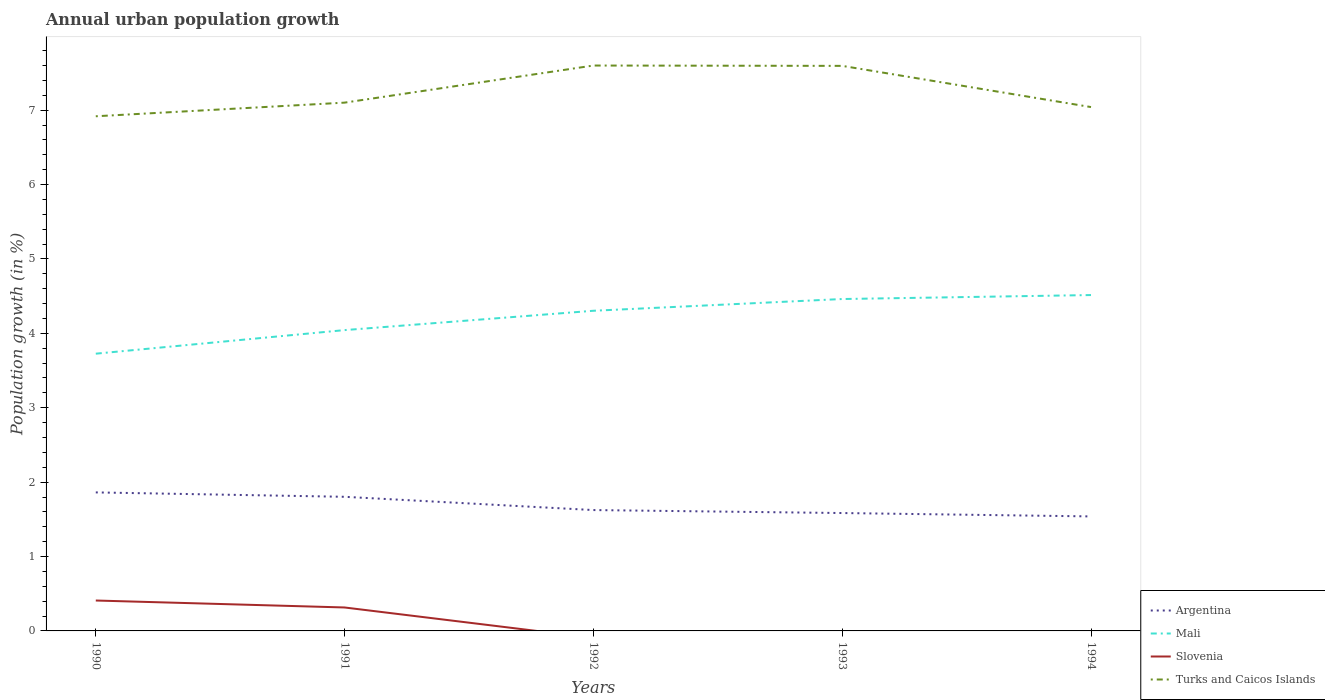Does the line corresponding to Turks and Caicos Islands intersect with the line corresponding to Argentina?
Your response must be concise. No. Is the number of lines equal to the number of legend labels?
Your answer should be very brief. No. Across all years, what is the maximum percentage of urban population growth in Mali?
Your answer should be very brief. 3.73. What is the total percentage of urban population growth in Argentina in the graph?
Keep it short and to the point. 0.24. What is the difference between the highest and the second highest percentage of urban population growth in Mali?
Give a very brief answer. 0.79. Is the percentage of urban population growth in Argentina strictly greater than the percentage of urban population growth in Slovenia over the years?
Keep it short and to the point. No. Where does the legend appear in the graph?
Give a very brief answer. Bottom right. How many legend labels are there?
Make the answer very short. 4. What is the title of the graph?
Your answer should be very brief. Annual urban population growth. Does "Korea (Republic)" appear as one of the legend labels in the graph?
Offer a terse response. No. What is the label or title of the X-axis?
Provide a short and direct response. Years. What is the label or title of the Y-axis?
Provide a succinct answer. Population growth (in %). What is the Population growth (in %) of Argentina in 1990?
Give a very brief answer. 1.86. What is the Population growth (in %) in Mali in 1990?
Your answer should be compact. 3.73. What is the Population growth (in %) in Slovenia in 1990?
Your response must be concise. 0.41. What is the Population growth (in %) of Turks and Caicos Islands in 1990?
Ensure brevity in your answer.  6.92. What is the Population growth (in %) in Argentina in 1991?
Ensure brevity in your answer.  1.8. What is the Population growth (in %) of Mali in 1991?
Offer a terse response. 4.04. What is the Population growth (in %) in Slovenia in 1991?
Your answer should be compact. 0.32. What is the Population growth (in %) in Turks and Caicos Islands in 1991?
Offer a terse response. 7.1. What is the Population growth (in %) in Argentina in 1992?
Your response must be concise. 1.62. What is the Population growth (in %) in Mali in 1992?
Offer a terse response. 4.3. What is the Population growth (in %) in Slovenia in 1992?
Provide a short and direct response. 0. What is the Population growth (in %) of Turks and Caicos Islands in 1992?
Keep it short and to the point. 7.6. What is the Population growth (in %) in Argentina in 1993?
Your answer should be compact. 1.58. What is the Population growth (in %) in Mali in 1993?
Give a very brief answer. 4.46. What is the Population growth (in %) of Turks and Caicos Islands in 1993?
Your response must be concise. 7.6. What is the Population growth (in %) of Argentina in 1994?
Give a very brief answer. 1.54. What is the Population growth (in %) in Mali in 1994?
Your response must be concise. 4.52. What is the Population growth (in %) of Turks and Caicos Islands in 1994?
Make the answer very short. 7.04. Across all years, what is the maximum Population growth (in %) of Argentina?
Keep it short and to the point. 1.86. Across all years, what is the maximum Population growth (in %) in Mali?
Ensure brevity in your answer.  4.52. Across all years, what is the maximum Population growth (in %) of Slovenia?
Provide a succinct answer. 0.41. Across all years, what is the maximum Population growth (in %) in Turks and Caicos Islands?
Your response must be concise. 7.6. Across all years, what is the minimum Population growth (in %) of Argentina?
Provide a succinct answer. 1.54. Across all years, what is the minimum Population growth (in %) in Mali?
Offer a very short reply. 3.73. Across all years, what is the minimum Population growth (in %) of Turks and Caicos Islands?
Ensure brevity in your answer.  6.92. What is the total Population growth (in %) in Argentina in the graph?
Provide a short and direct response. 8.41. What is the total Population growth (in %) in Mali in the graph?
Ensure brevity in your answer.  21.05. What is the total Population growth (in %) of Slovenia in the graph?
Offer a terse response. 0.72. What is the total Population growth (in %) of Turks and Caicos Islands in the graph?
Provide a succinct answer. 36.26. What is the difference between the Population growth (in %) of Argentina in 1990 and that in 1991?
Provide a succinct answer. 0.06. What is the difference between the Population growth (in %) of Mali in 1990 and that in 1991?
Provide a short and direct response. -0.32. What is the difference between the Population growth (in %) of Slovenia in 1990 and that in 1991?
Your answer should be very brief. 0.09. What is the difference between the Population growth (in %) of Turks and Caicos Islands in 1990 and that in 1991?
Keep it short and to the point. -0.18. What is the difference between the Population growth (in %) in Argentina in 1990 and that in 1992?
Ensure brevity in your answer.  0.24. What is the difference between the Population growth (in %) of Mali in 1990 and that in 1992?
Give a very brief answer. -0.58. What is the difference between the Population growth (in %) of Turks and Caicos Islands in 1990 and that in 1992?
Provide a succinct answer. -0.68. What is the difference between the Population growth (in %) in Argentina in 1990 and that in 1993?
Ensure brevity in your answer.  0.28. What is the difference between the Population growth (in %) of Mali in 1990 and that in 1993?
Ensure brevity in your answer.  -0.73. What is the difference between the Population growth (in %) of Turks and Caicos Islands in 1990 and that in 1993?
Ensure brevity in your answer.  -0.68. What is the difference between the Population growth (in %) in Argentina in 1990 and that in 1994?
Offer a very short reply. 0.32. What is the difference between the Population growth (in %) of Mali in 1990 and that in 1994?
Your response must be concise. -0.79. What is the difference between the Population growth (in %) in Turks and Caicos Islands in 1990 and that in 1994?
Ensure brevity in your answer.  -0.12. What is the difference between the Population growth (in %) of Argentina in 1991 and that in 1992?
Your answer should be very brief. 0.18. What is the difference between the Population growth (in %) of Mali in 1991 and that in 1992?
Your answer should be very brief. -0.26. What is the difference between the Population growth (in %) of Turks and Caicos Islands in 1991 and that in 1992?
Keep it short and to the point. -0.5. What is the difference between the Population growth (in %) in Argentina in 1991 and that in 1993?
Offer a very short reply. 0.22. What is the difference between the Population growth (in %) of Mali in 1991 and that in 1993?
Your answer should be very brief. -0.42. What is the difference between the Population growth (in %) in Turks and Caicos Islands in 1991 and that in 1993?
Your answer should be compact. -0.49. What is the difference between the Population growth (in %) of Argentina in 1991 and that in 1994?
Make the answer very short. 0.26. What is the difference between the Population growth (in %) in Mali in 1991 and that in 1994?
Offer a very short reply. -0.47. What is the difference between the Population growth (in %) in Turks and Caicos Islands in 1991 and that in 1994?
Offer a terse response. 0.06. What is the difference between the Population growth (in %) in Mali in 1992 and that in 1993?
Your response must be concise. -0.16. What is the difference between the Population growth (in %) in Turks and Caicos Islands in 1992 and that in 1993?
Provide a succinct answer. 0. What is the difference between the Population growth (in %) in Argentina in 1992 and that in 1994?
Ensure brevity in your answer.  0.09. What is the difference between the Population growth (in %) in Mali in 1992 and that in 1994?
Make the answer very short. -0.21. What is the difference between the Population growth (in %) in Turks and Caicos Islands in 1992 and that in 1994?
Your response must be concise. 0.56. What is the difference between the Population growth (in %) of Argentina in 1993 and that in 1994?
Ensure brevity in your answer.  0.05. What is the difference between the Population growth (in %) of Mali in 1993 and that in 1994?
Your answer should be very brief. -0.05. What is the difference between the Population growth (in %) of Turks and Caicos Islands in 1993 and that in 1994?
Keep it short and to the point. 0.55. What is the difference between the Population growth (in %) in Argentina in 1990 and the Population growth (in %) in Mali in 1991?
Offer a terse response. -2.18. What is the difference between the Population growth (in %) of Argentina in 1990 and the Population growth (in %) of Slovenia in 1991?
Give a very brief answer. 1.55. What is the difference between the Population growth (in %) of Argentina in 1990 and the Population growth (in %) of Turks and Caicos Islands in 1991?
Offer a very short reply. -5.24. What is the difference between the Population growth (in %) in Mali in 1990 and the Population growth (in %) in Slovenia in 1991?
Your answer should be compact. 3.41. What is the difference between the Population growth (in %) of Mali in 1990 and the Population growth (in %) of Turks and Caicos Islands in 1991?
Your response must be concise. -3.37. What is the difference between the Population growth (in %) in Slovenia in 1990 and the Population growth (in %) in Turks and Caicos Islands in 1991?
Ensure brevity in your answer.  -6.69. What is the difference between the Population growth (in %) of Argentina in 1990 and the Population growth (in %) of Mali in 1992?
Your answer should be compact. -2.44. What is the difference between the Population growth (in %) in Argentina in 1990 and the Population growth (in %) in Turks and Caicos Islands in 1992?
Your response must be concise. -5.74. What is the difference between the Population growth (in %) in Mali in 1990 and the Population growth (in %) in Turks and Caicos Islands in 1992?
Keep it short and to the point. -3.87. What is the difference between the Population growth (in %) of Slovenia in 1990 and the Population growth (in %) of Turks and Caicos Islands in 1992?
Ensure brevity in your answer.  -7.19. What is the difference between the Population growth (in %) of Argentina in 1990 and the Population growth (in %) of Mali in 1993?
Keep it short and to the point. -2.6. What is the difference between the Population growth (in %) of Argentina in 1990 and the Population growth (in %) of Turks and Caicos Islands in 1993?
Offer a very short reply. -5.73. What is the difference between the Population growth (in %) of Mali in 1990 and the Population growth (in %) of Turks and Caicos Islands in 1993?
Provide a succinct answer. -3.87. What is the difference between the Population growth (in %) of Slovenia in 1990 and the Population growth (in %) of Turks and Caicos Islands in 1993?
Your answer should be very brief. -7.19. What is the difference between the Population growth (in %) of Argentina in 1990 and the Population growth (in %) of Mali in 1994?
Provide a succinct answer. -2.65. What is the difference between the Population growth (in %) of Argentina in 1990 and the Population growth (in %) of Turks and Caicos Islands in 1994?
Offer a terse response. -5.18. What is the difference between the Population growth (in %) of Mali in 1990 and the Population growth (in %) of Turks and Caicos Islands in 1994?
Your response must be concise. -3.32. What is the difference between the Population growth (in %) of Slovenia in 1990 and the Population growth (in %) of Turks and Caicos Islands in 1994?
Provide a succinct answer. -6.63. What is the difference between the Population growth (in %) in Argentina in 1991 and the Population growth (in %) in Mali in 1992?
Keep it short and to the point. -2.5. What is the difference between the Population growth (in %) of Argentina in 1991 and the Population growth (in %) of Turks and Caicos Islands in 1992?
Make the answer very short. -5.8. What is the difference between the Population growth (in %) of Mali in 1991 and the Population growth (in %) of Turks and Caicos Islands in 1992?
Make the answer very short. -3.56. What is the difference between the Population growth (in %) in Slovenia in 1991 and the Population growth (in %) in Turks and Caicos Islands in 1992?
Make the answer very short. -7.29. What is the difference between the Population growth (in %) of Argentina in 1991 and the Population growth (in %) of Mali in 1993?
Ensure brevity in your answer.  -2.66. What is the difference between the Population growth (in %) of Argentina in 1991 and the Population growth (in %) of Turks and Caicos Islands in 1993?
Provide a short and direct response. -5.79. What is the difference between the Population growth (in %) in Mali in 1991 and the Population growth (in %) in Turks and Caicos Islands in 1993?
Keep it short and to the point. -3.55. What is the difference between the Population growth (in %) of Slovenia in 1991 and the Population growth (in %) of Turks and Caicos Islands in 1993?
Keep it short and to the point. -7.28. What is the difference between the Population growth (in %) in Argentina in 1991 and the Population growth (in %) in Mali in 1994?
Your answer should be compact. -2.71. What is the difference between the Population growth (in %) of Argentina in 1991 and the Population growth (in %) of Turks and Caicos Islands in 1994?
Keep it short and to the point. -5.24. What is the difference between the Population growth (in %) in Mali in 1991 and the Population growth (in %) in Turks and Caicos Islands in 1994?
Give a very brief answer. -3. What is the difference between the Population growth (in %) in Slovenia in 1991 and the Population growth (in %) in Turks and Caicos Islands in 1994?
Your answer should be compact. -6.73. What is the difference between the Population growth (in %) in Argentina in 1992 and the Population growth (in %) in Mali in 1993?
Make the answer very short. -2.84. What is the difference between the Population growth (in %) in Argentina in 1992 and the Population growth (in %) in Turks and Caicos Islands in 1993?
Make the answer very short. -5.97. What is the difference between the Population growth (in %) in Mali in 1992 and the Population growth (in %) in Turks and Caicos Islands in 1993?
Offer a very short reply. -3.29. What is the difference between the Population growth (in %) of Argentina in 1992 and the Population growth (in %) of Mali in 1994?
Offer a terse response. -2.89. What is the difference between the Population growth (in %) of Argentina in 1992 and the Population growth (in %) of Turks and Caicos Islands in 1994?
Provide a short and direct response. -5.42. What is the difference between the Population growth (in %) of Mali in 1992 and the Population growth (in %) of Turks and Caicos Islands in 1994?
Offer a very short reply. -2.74. What is the difference between the Population growth (in %) in Argentina in 1993 and the Population growth (in %) in Mali in 1994?
Keep it short and to the point. -2.93. What is the difference between the Population growth (in %) in Argentina in 1993 and the Population growth (in %) in Turks and Caicos Islands in 1994?
Your answer should be very brief. -5.46. What is the difference between the Population growth (in %) of Mali in 1993 and the Population growth (in %) of Turks and Caicos Islands in 1994?
Provide a succinct answer. -2.58. What is the average Population growth (in %) in Argentina per year?
Your response must be concise. 1.68. What is the average Population growth (in %) in Mali per year?
Your response must be concise. 4.21. What is the average Population growth (in %) in Slovenia per year?
Ensure brevity in your answer.  0.14. What is the average Population growth (in %) of Turks and Caicos Islands per year?
Offer a very short reply. 7.25. In the year 1990, what is the difference between the Population growth (in %) of Argentina and Population growth (in %) of Mali?
Your response must be concise. -1.86. In the year 1990, what is the difference between the Population growth (in %) in Argentina and Population growth (in %) in Slovenia?
Your answer should be compact. 1.45. In the year 1990, what is the difference between the Population growth (in %) of Argentina and Population growth (in %) of Turks and Caicos Islands?
Make the answer very short. -5.06. In the year 1990, what is the difference between the Population growth (in %) in Mali and Population growth (in %) in Slovenia?
Your answer should be compact. 3.32. In the year 1990, what is the difference between the Population growth (in %) in Mali and Population growth (in %) in Turks and Caicos Islands?
Keep it short and to the point. -3.19. In the year 1990, what is the difference between the Population growth (in %) in Slovenia and Population growth (in %) in Turks and Caicos Islands?
Offer a very short reply. -6.51. In the year 1991, what is the difference between the Population growth (in %) of Argentina and Population growth (in %) of Mali?
Offer a terse response. -2.24. In the year 1991, what is the difference between the Population growth (in %) of Argentina and Population growth (in %) of Slovenia?
Offer a terse response. 1.49. In the year 1991, what is the difference between the Population growth (in %) in Argentina and Population growth (in %) in Turks and Caicos Islands?
Offer a very short reply. -5.3. In the year 1991, what is the difference between the Population growth (in %) of Mali and Population growth (in %) of Slovenia?
Make the answer very short. 3.73. In the year 1991, what is the difference between the Population growth (in %) of Mali and Population growth (in %) of Turks and Caicos Islands?
Provide a succinct answer. -3.06. In the year 1991, what is the difference between the Population growth (in %) of Slovenia and Population growth (in %) of Turks and Caicos Islands?
Provide a succinct answer. -6.79. In the year 1992, what is the difference between the Population growth (in %) of Argentina and Population growth (in %) of Mali?
Offer a terse response. -2.68. In the year 1992, what is the difference between the Population growth (in %) of Argentina and Population growth (in %) of Turks and Caicos Islands?
Your answer should be very brief. -5.98. In the year 1992, what is the difference between the Population growth (in %) of Mali and Population growth (in %) of Turks and Caicos Islands?
Offer a very short reply. -3.3. In the year 1993, what is the difference between the Population growth (in %) of Argentina and Population growth (in %) of Mali?
Provide a short and direct response. -2.88. In the year 1993, what is the difference between the Population growth (in %) in Argentina and Population growth (in %) in Turks and Caicos Islands?
Your answer should be very brief. -6.01. In the year 1993, what is the difference between the Population growth (in %) of Mali and Population growth (in %) of Turks and Caicos Islands?
Keep it short and to the point. -3.13. In the year 1994, what is the difference between the Population growth (in %) in Argentina and Population growth (in %) in Mali?
Your answer should be very brief. -2.98. In the year 1994, what is the difference between the Population growth (in %) in Argentina and Population growth (in %) in Turks and Caicos Islands?
Keep it short and to the point. -5.5. In the year 1994, what is the difference between the Population growth (in %) in Mali and Population growth (in %) in Turks and Caicos Islands?
Offer a very short reply. -2.53. What is the ratio of the Population growth (in %) in Argentina in 1990 to that in 1991?
Offer a terse response. 1.03. What is the ratio of the Population growth (in %) in Mali in 1990 to that in 1991?
Your response must be concise. 0.92. What is the ratio of the Population growth (in %) of Slovenia in 1990 to that in 1991?
Your response must be concise. 1.3. What is the ratio of the Population growth (in %) in Turks and Caicos Islands in 1990 to that in 1991?
Offer a terse response. 0.97. What is the ratio of the Population growth (in %) in Argentina in 1990 to that in 1992?
Offer a terse response. 1.15. What is the ratio of the Population growth (in %) in Mali in 1990 to that in 1992?
Give a very brief answer. 0.87. What is the ratio of the Population growth (in %) of Turks and Caicos Islands in 1990 to that in 1992?
Give a very brief answer. 0.91. What is the ratio of the Population growth (in %) of Argentina in 1990 to that in 1993?
Your answer should be very brief. 1.18. What is the ratio of the Population growth (in %) in Mali in 1990 to that in 1993?
Offer a very short reply. 0.84. What is the ratio of the Population growth (in %) in Turks and Caicos Islands in 1990 to that in 1993?
Make the answer very short. 0.91. What is the ratio of the Population growth (in %) in Argentina in 1990 to that in 1994?
Your answer should be compact. 1.21. What is the ratio of the Population growth (in %) in Mali in 1990 to that in 1994?
Make the answer very short. 0.83. What is the ratio of the Population growth (in %) in Turks and Caicos Islands in 1990 to that in 1994?
Provide a short and direct response. 0.98. What is the ratio of the Population growth (in %) in Argentina in 1991 to that in 1992?
Offer a very short reply. 1.11. What is the ratio of the Population growth (in %) of Mali in 1991 to that in 1992?
Ensure brevity in your answer.  0.94. What is the ratio of the Population growth (in %) of Turks and Caicos Islands in 1991 to that in 1992?
Ensure brevity in your answer.  0.93. What is the ratio of the Population growth (in %) in Argentina in 1991 to that in 1993?
Ensure brevity in your answer.  1.14. What is the ratio of the Population growth (in %) of Mali in 1991 to that in 1993?
Make the answer very short. 0.91. What is the ratio of the Population growth (in %) in Turks and Caicos Islands in 1991 to that in 1993?
Make the answer very short. 0.93. What is the ratio of the Population growth (in %) in Argentina in 1991 to that in 1994?
Keep it short and to the point. 1.17. What is the ratio of the Population growth (in %) of Mali in 1991 to that in 1994?
Offer a very short reply. 0.9. What is the ratio of the Population growth (in %) of Turks and Caicos Islands in 1991 to that in 1994?
Provide a short and direct response. 1.01. What is the ratio of the Population growth (in %) in Argentina in 1992 to that in 1993?
Offer a very short reply. 1.03. What is the ratio of the Population growth (in %) of Mali in 1992 to that in 1993?
Provide a short and direct response. 0.96. What is the ratio of the Population growth (in %) of Argentina in 1992 to that in 1994?
Offer a very short reply. 1.06. What is the ratio of the Population growth (in %) of Mali in 1992 to that in 1994?
Ensure brevity in your answer.  0.95. What is the ratio of the Population growth (in %) in Turks and Caicos Islands in 1992 to that in 1994?
Keep it short and to the point. 1.08. What is the ratio of the Population growth (in %) in Argentina in 1993 to that in 1994?
Offer a very short reply. 1.03. What is the ratio of the Population growth (in %) of Mali in 1993 to that in 1994?
Provide a short and direct response. 0.99. What is the ratio of the Population growth (in %) of Turks and Caicos Islands in 1993 to that in 1994?
Offer a very short reply. 1.08. What is the difference between the highest and the second highest Population growth (in %) of Argentina?
Your answer should be very brief. 0.06. What is the difference between the highest and the second highest Population growth (in %) in Mali?
Your answer should be compact. 0.05. What is the difference between the highest and the second highest Population growth (in %) of Turks and Caicos Islands?
Keep it short and to the point. 0. What is the difference between the highest and the lowest Population growth (in %) in Argentina?
Offer a terse response. 0.32. What is the difference between the highest and the lowest Population growth (in %) in Mali?
Provide a short and direct response. 0.79. What is the difference between the highest and the lowest Population growth (in %) of Slovenia?
Provide a short and direct response. 0.41. What is the difference between the highest and the lowest Population growth (in %) in Turks and Caicos Islands?
Your response must be concise. 0.68. 